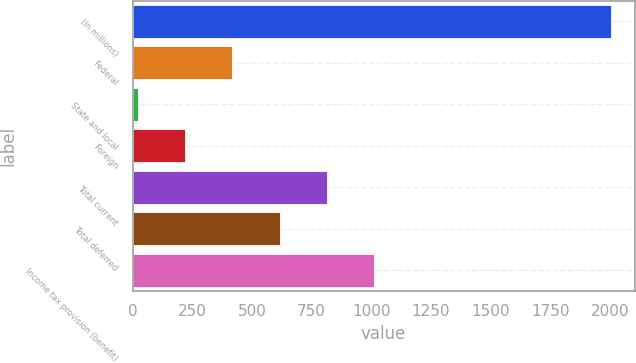<chart> <loc_0><loc_0><loc_500><loc_500><bar_chart><fcel>(In millions)<fcel>Federal<fcel>State and local<fcel>Foreign<fcel>Total current<fcel>Total deferred<fcel>Income tax provision (benefit)<nl><fcel>2003<fcel>417.48<fcel>21.1<fcel>219.29<fcel>813.86<fcel>615.67<fcel>1012.05<nl></chart> 